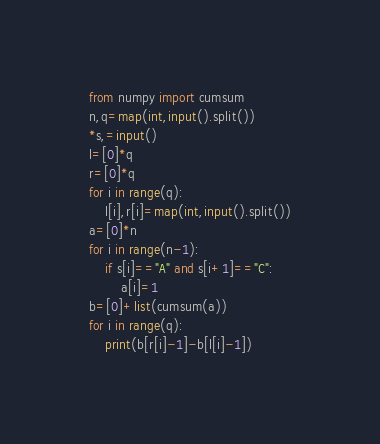Convert code to text. <code><loc_0><loc_0><loc_500><loc_500><_Python_>from numpy import cumsum
n,q=map(int,input().split())
*s,=input()
l=[0]*q
r=[0]*q
for i in range(q):
    l[i],r[i]=map(int,input().split())
a=[0]*n
for i in range(n-1):
    if s[i]=="A" and s[i+1]=="C":
        a[i]=1
b=[0]+list(cumsum(a))
for i in range(q):
    print(b[r[i]-1]-b[l[i]-1])</code> 